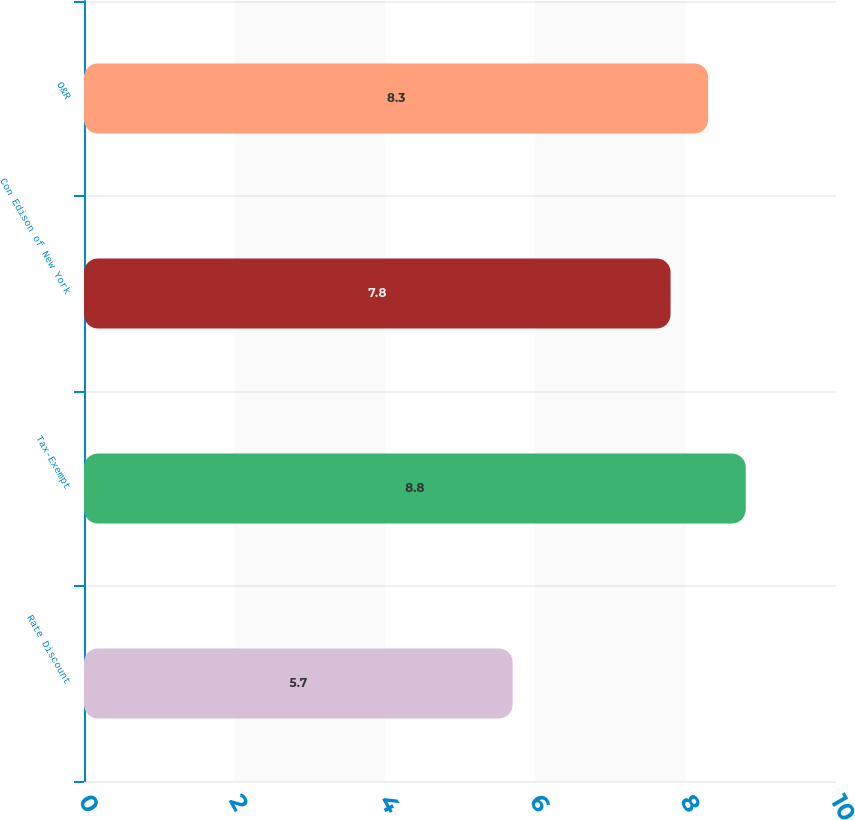<chart> <loc_0><loc_0><loc_500><loc_500><bar_chart><fcel>Rate Discount<fcel>Tax-Exempt<fcel>Con Edison of New York<fcel>O&R<nl><fcel>5.7<fcel>8.8<fcel>7.8<fcel>8.3<nl></chart> 